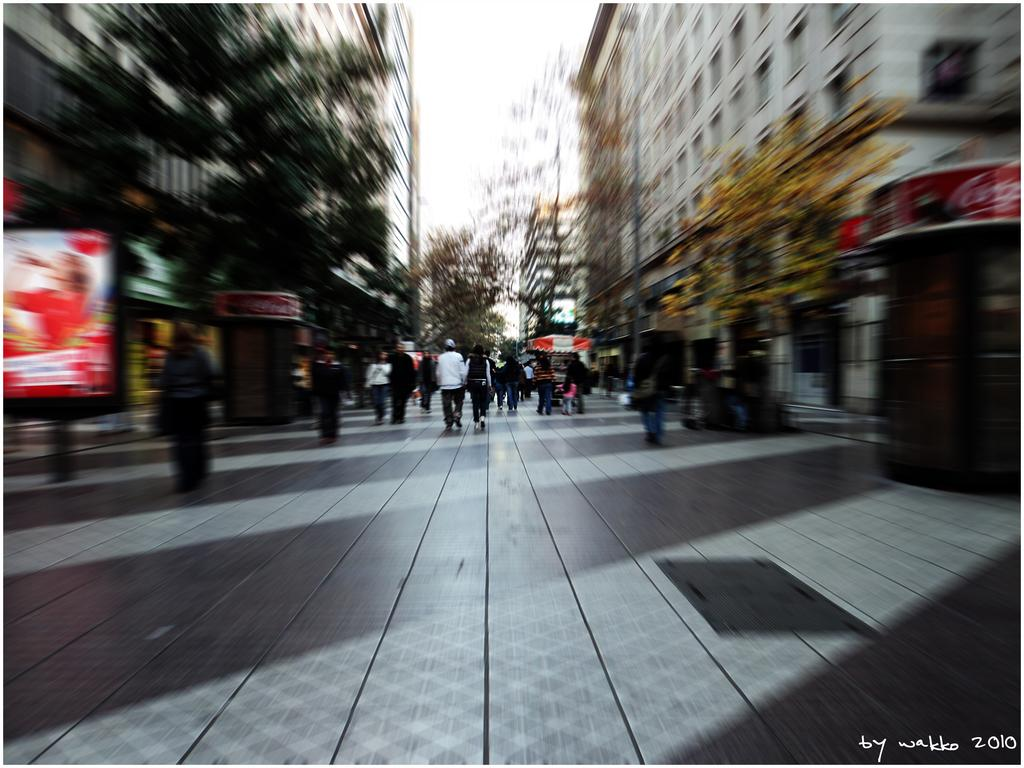What is happening with the group of people in the image? The group of people is on the ground in the image. What can be seen in the background of the image? There are buildings, trees, and the sky visible in the background of the image. Are there any other objects present in the background of the image? Yes, there are some objects in the background of the image. Where is the text located in the image? The text is in the bottom right corner of the image. What type of tin can be seen in the image? There is no tin present in the image. What color is the butter in the image? There is no butter present in the image. 